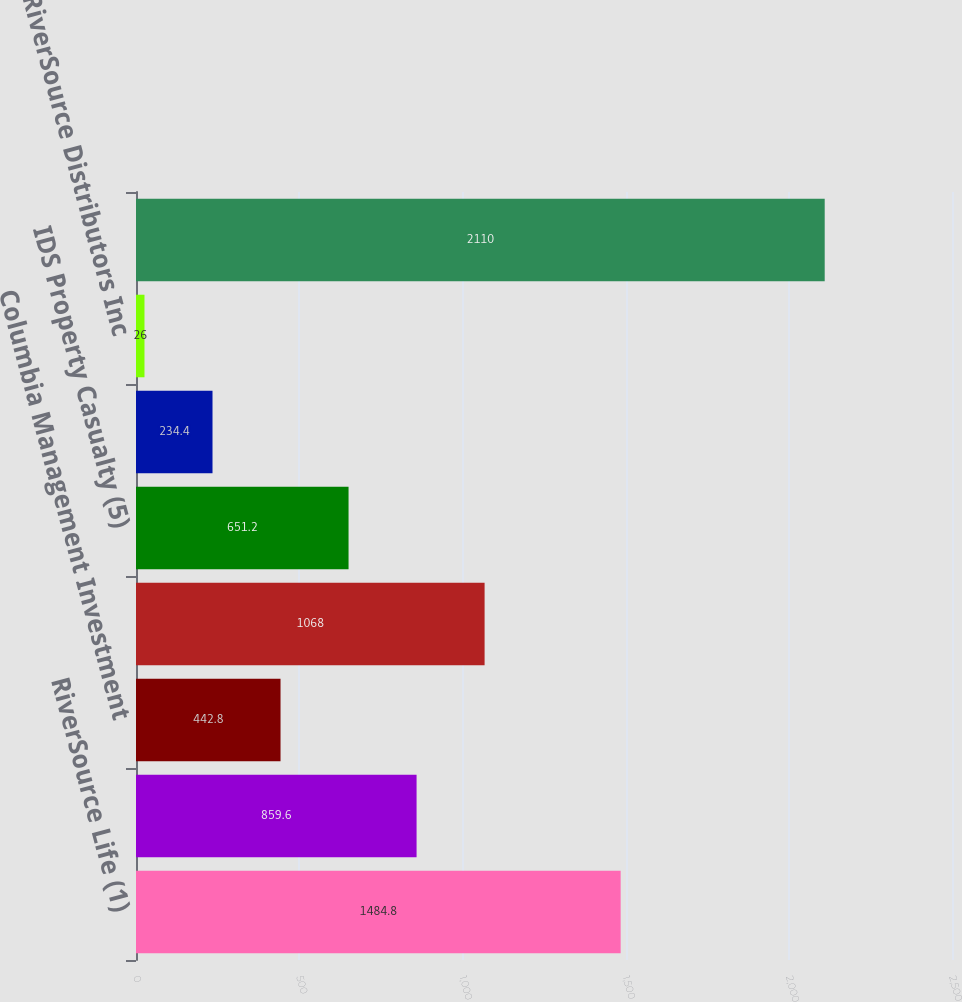Convert chart to OTSL. <chart><loc_0><loc_0><loc_500><loc_500><bar_chart><fcel>RiverSource Life (1)<fcel>ACC (3)<fcel>Columbia Management Investment<fcel>Threadneedle<fcel>IDS Property Casualty (5)<fcel>Ameriprise Captive Insurance<fcel>RiverSource Distributors Inc<fcel>Total dividend capacity<nl><fcel>1484.8<fcel>859.6<fcel>442.8<fcel>1068<fcel>651.2<fcel>234.4<fcel>26<fcel>2110<nl></chart> 